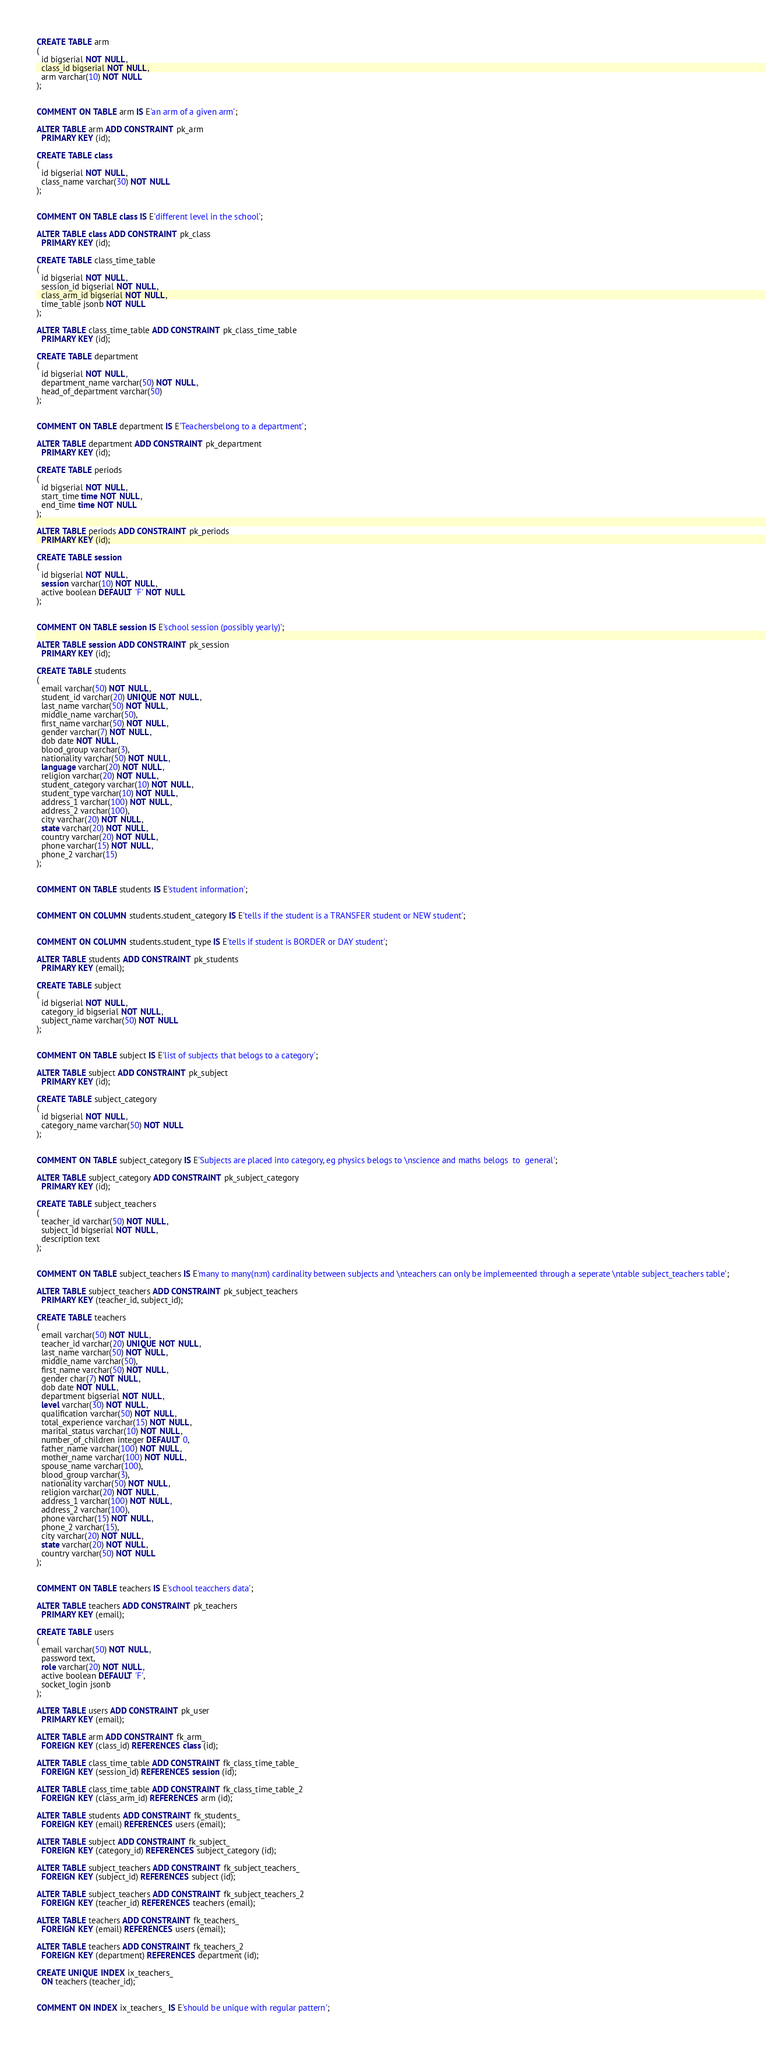Convert code to text. <code><loc_0><loc_0><loc_500><loc_500><_SQL_>CREATE TABLE arm
(
  id bigserial NOT NULL,
  class_id bigserial NOT NULL,
  arm varchar(10) NOT NULL
);


COMMENT ON TABLE arm IS E'an arm of a given arm';

ALTER TABLE arm ADD CONSTRAINT pk_arm
  PRIMARY KEY (id);

CREATE TABLE class
(
  id bigserial NOT NULL,
  class_name varchar(30) NOT NULL
);


COMMENT ON TABLE class IS E'different level in the school';

ALTER TABLE class ADD CONSTRAINT pk_class
  PRIMARY KEY (id);

CREATE TABLE class_time_table
(
  id bigserial NOT NULL,
  session_id bigserial NOT NULL,
  class_arm_id bigserial NOT NULL,
  time_table jsonb NOT NULL
);

ALTER TABLE class_time_table ADD CONSTRAINT pk_class_time_table
  PRIMARY KEY (id);

CREATE TABLE department
(
  id bigserial NOT NULL,
  department_name varchar(50) NOT NULL,
  head_of_department varchar(50)
);


COMMENT ON TABLE department IS E'Teachersbelong to a department';

ALTER TABLE department ADD CONSTRAINT pk_department
  PRIMARY KEY (id);

CREATE TABLE periods
(
  id bigserial NOT NULL,
  start_time time NOT NULL,
  end_time time NOT NULL
);

ALTER TABLE periods ADD CONSTRAINT pk_periods
  PRIMARY KEY (id);

CREATE TABLE session
(
  id bigserial NOT NULL,
  session varchar(10) NOT NULL,
  active boolean DEFAULT 'F' NOT NULL
);


COMMENT ON TABLE session IS E'school session (possibly yearly)';

ALTER TABLE session ADD CONSTRAINT pk_session
  PRIMARY KEY (id);

CREATE TABLE students
(
  email varchar(50) NOT NULL,
  student_id varchar(20) UNIQUE NOT NULL,
  last_name varchar(50) NOT NULL,
  middle_name varchar(50),
  first_name varchar(50) NOT NULL,
  gender varchar(7) NOT NULL,
  dob date NOT NULL,
  blood_group varchar(3),
  nationality varchar(50) NOT NULL,
  language varchar(20) NOT NULL,
  religion varchar(20) NOT NULL,
  student_category varchar(10) NOT NULL,
  student_type varchar(10) NOT NULL,
  address_1 varchar(100) NOT NULL,
  address_2 varchar(100),
  city varchar(20) NOT NULL,
  state varchar(20) NOT NULL,
  country varchar(20) NOT NULL,
  phone varchar(15) NOT NULL,
  phone_2 varchar(15)
);


COMMENT ON TABLE students IS E'student information';


COMMENT ON COLUMN students.student_category IS E'tells if the student is a TRANSFER student or NEW student';


COMMENT ON COLUMN students.student_type IS E'tells if student is BORDER or DAY student';

ALTER TABLE students ADD CONSTRAINT pk_students
  PRIMARY KEY (email);

CREATE TABLE subject
(
  id bigserial NOT NULL,
  category_id bigserial NOT NULL,
  subject_name varchar(50) NOT NULL
);


COMMENT ON TABLE subject IS E'list of subjects that belogs to a category';

ALTER TABLE subject ADD CONSTRAINT pk_subject
  PRIMARY KEY (id);

CREATE TABLE subject_category
(
  id bigserial NOT NULL,
  category_name varchar(50) NOT NULL
);


COMMENT ON TABLE subject_category IS E'Subjects are placed into category, eg physics belogs to \nscience and maths belogs  to  general';

ALTER TABLE subject_category ADD CONSTRAINT pk_subject_category
  PRIMARY KEY (id);

CREATE TABLE subject_teachers
(
  teacher_id varchar(50) NOT NULL,
  subject_id bigserial NOT NULL,
  description text
);


COMMENT ON TABLE subject_teachers IS E'many to many(n:m) cardinality between subjects and \nteachers can only be implemeented through a seperate \ntable subject_teachers table';

ALTER TABLE subject_teachers ADD CONSTRAINT pk_subject_teachers
  PRIMARY KEY (teacher_id, subject_id);

CREATE TABLE teachers
(
  email varchar(50) NOT NULL,
  teacher_id varchar(20) UNIQUE NOT NULL,
  last_name varchar(50) NOT NULL,
  middle_name varchar(50),
  first_name varchar(50) NOT NULL,
  gender char(7) NOT NULL,
  dob date NOT NULL,
  department bigserial NOT NULL,
  level varchar(30) NOT NULL,
  qualification varchar(50) NOT NULL,
  total_experience varchar(15) NOT NULL,
  marital_status varchar(10) NOT NULL,
  number_of_children integer DEFAULT 0,
  father_name varchar(100) NOT NULL,
  mother_name varchar(100) NOT NULL,
  spouse_name varchar(100),
  blood_group varchar(3),
  nationality varchar(50) NOT NULL,
  religion varchar(20) NOT NULL,
  address_1 varchar(100) NOT NULL,
  address_2 varchar(100),
  phone varchar(15) NOT NULL,
  phone_2 varchar(15),
  city varchar(20) NOT NULL,
  state varchar(20) NOT NULL,
  country varchar(50) NOT NULL
);


COMMENT ON TABLE teachers IS E'school teacchers data';

ALTER TABLE teachers ADD CONSTRAINT pk_teachers
  PRIMARY KEY (email);

CREATE TABLE users
(
  email varchar(50) NOT NULL,
  password text,
  role varchar(20) NOT NULL,
  active boolean DEFAULT 'F',
  socket_login jsonb
);

ALTER TABLE users ADD CONSTRAINT pk_user
  PRIMARY KEY (email);

ALTER TABLE arm ADD CONSTRAINT fk_arm_
  FOREIGN KEY (class_id) REFERENCES class (id);

ALTER TABLE class_time_table ADD CONSTRAINT fk_class_time_table_
  FOREIGN KEY (session_id) REFERENCES session (id);

ALTER TABLE class_time_table ADD CONSTRAINT fk_class_time_table_2
  FOREIGN KEY (class_arm_id) REFERENCES arm (id);

ALTER TABLE students ADD CONSTRAINT fk_students_
  FOREIGN KEY (email) REFERENCES users (email);

ALTER TABLE subject ADD CONSTRAINT fk_subject_
  FOREIGN KEY (category_id) REFERENCES subject_category (id);

ALTER TABLE subject_teachers ADD CONSTRAINT fk_subject_teachers_
  FOREIGN KEY (subject_id) REFERENCES subject (id);

ALTER TABLE subject_teachers ADD CONSTRAINT fk_subject_teachers_2
  FOREIGN KEY (teacher_id) REFERENCES teachers (email);

ALTER TABLE teachers ADD CONSTRAINT fk_teachers_
  FOREIGN KEY (email) REFERENCES users (email);

ALTER TABLE teachers ADD CONSTRAINT fk_teachers_2
  FOREIGN KEY (department) REFERENCES department (id);

CREATE UNIQUE INDEX ix_teachers_
  ON teachers (teacher_id);


COMMENT ON INDEX ix_teachers_ IS E'should be unique with regular pattern';

</code> 